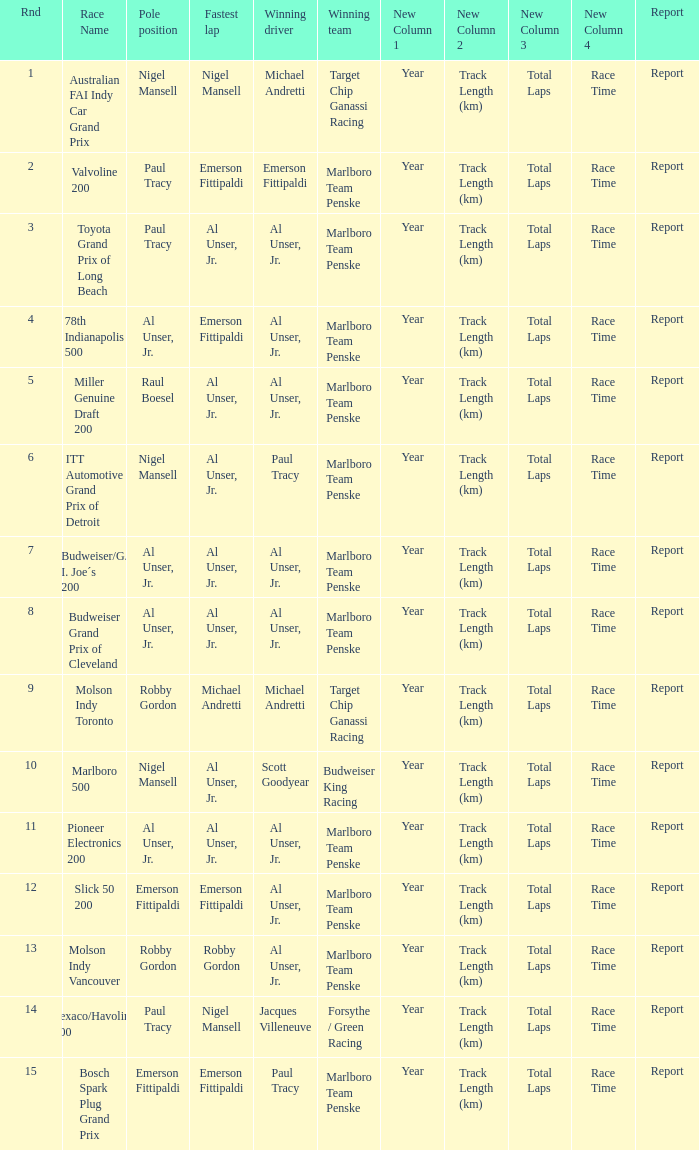Who was at the pole position in the ITT Automotive Grand Prix of Detroit, won by Paul Tracy? Nigel Mansell. 